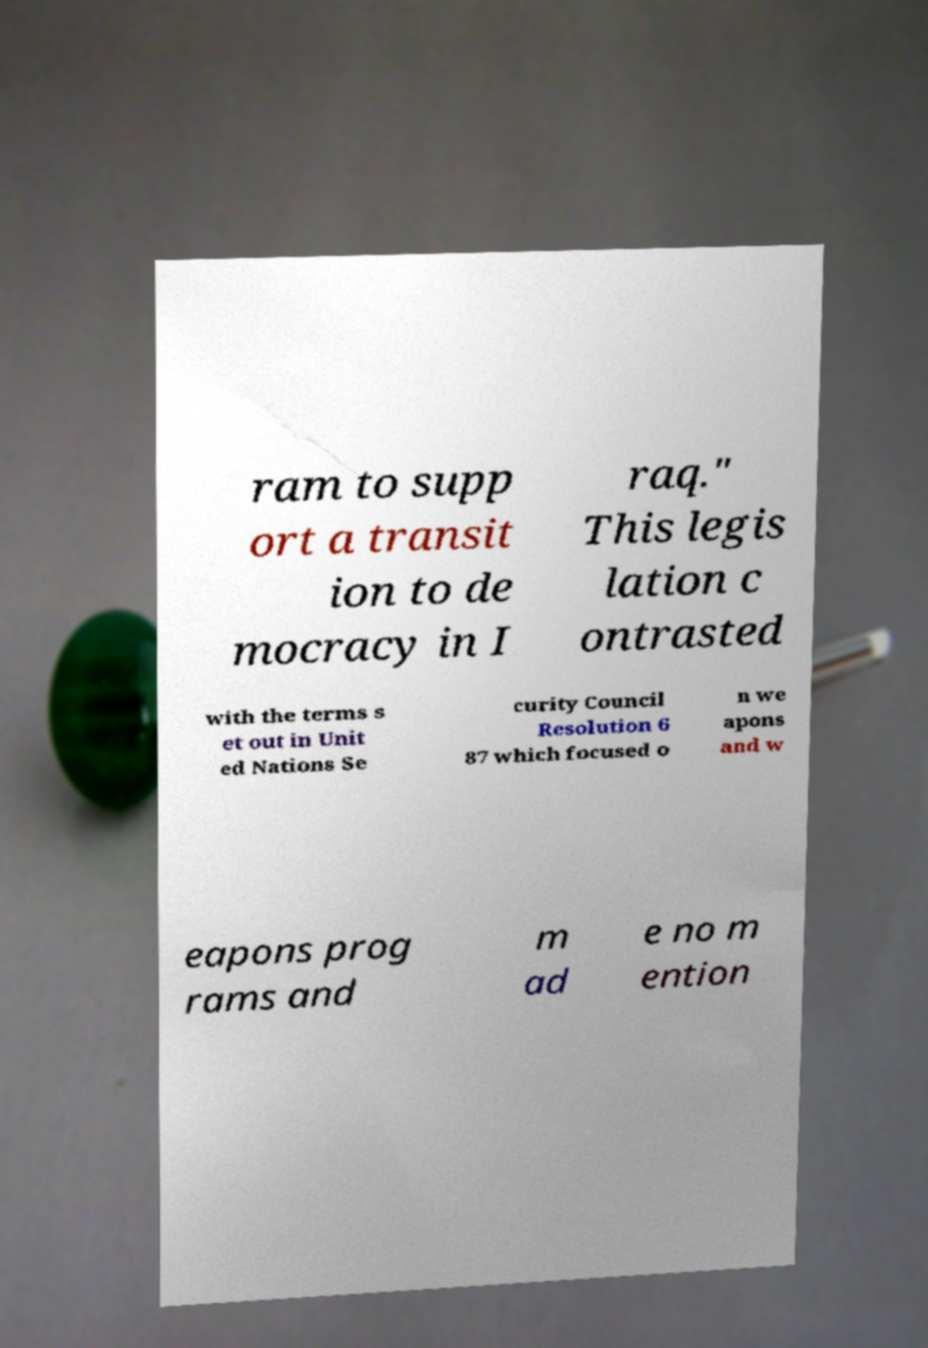Could you assist in decoding the text presented in this image and type it out clearly? ram to supp ort a transit ion to de mocracy in I raq." This legis lation c ontrasted with the terms s et out in Unit ed Nations Se curity Council Resolution 6 87 which focused o n we apons and w eapons prog rams and m ad e no m ention 